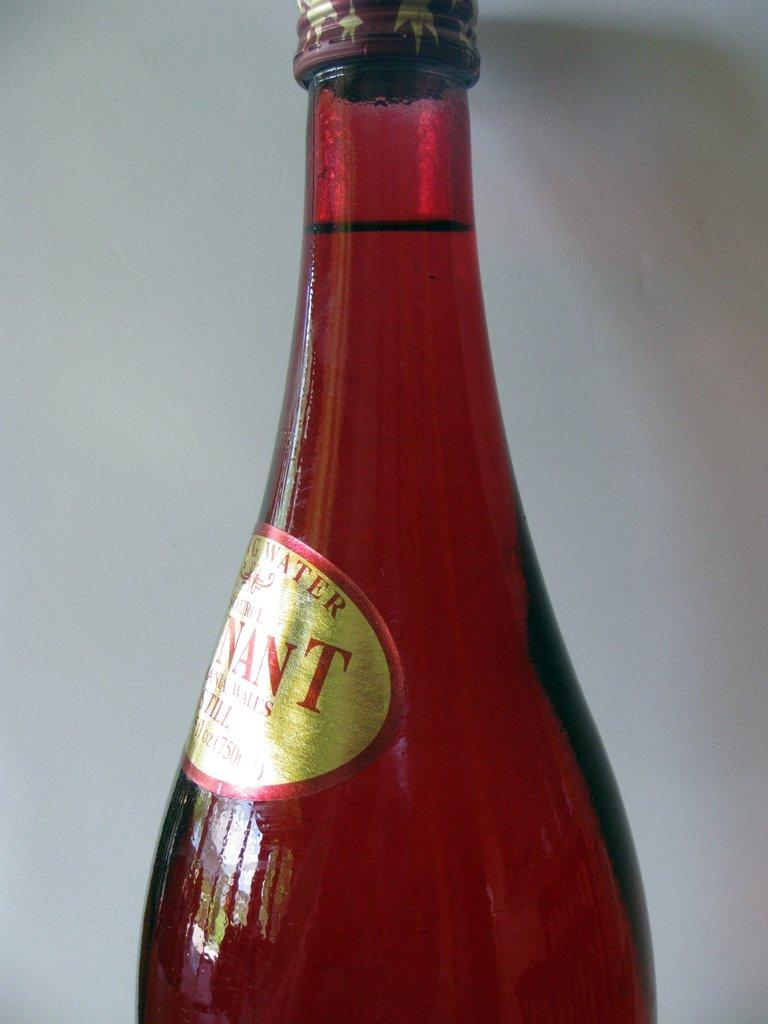<image>
Write a terse but informative summary of the picture. A bottle of spring water with the letters NANT on it is unopened. 